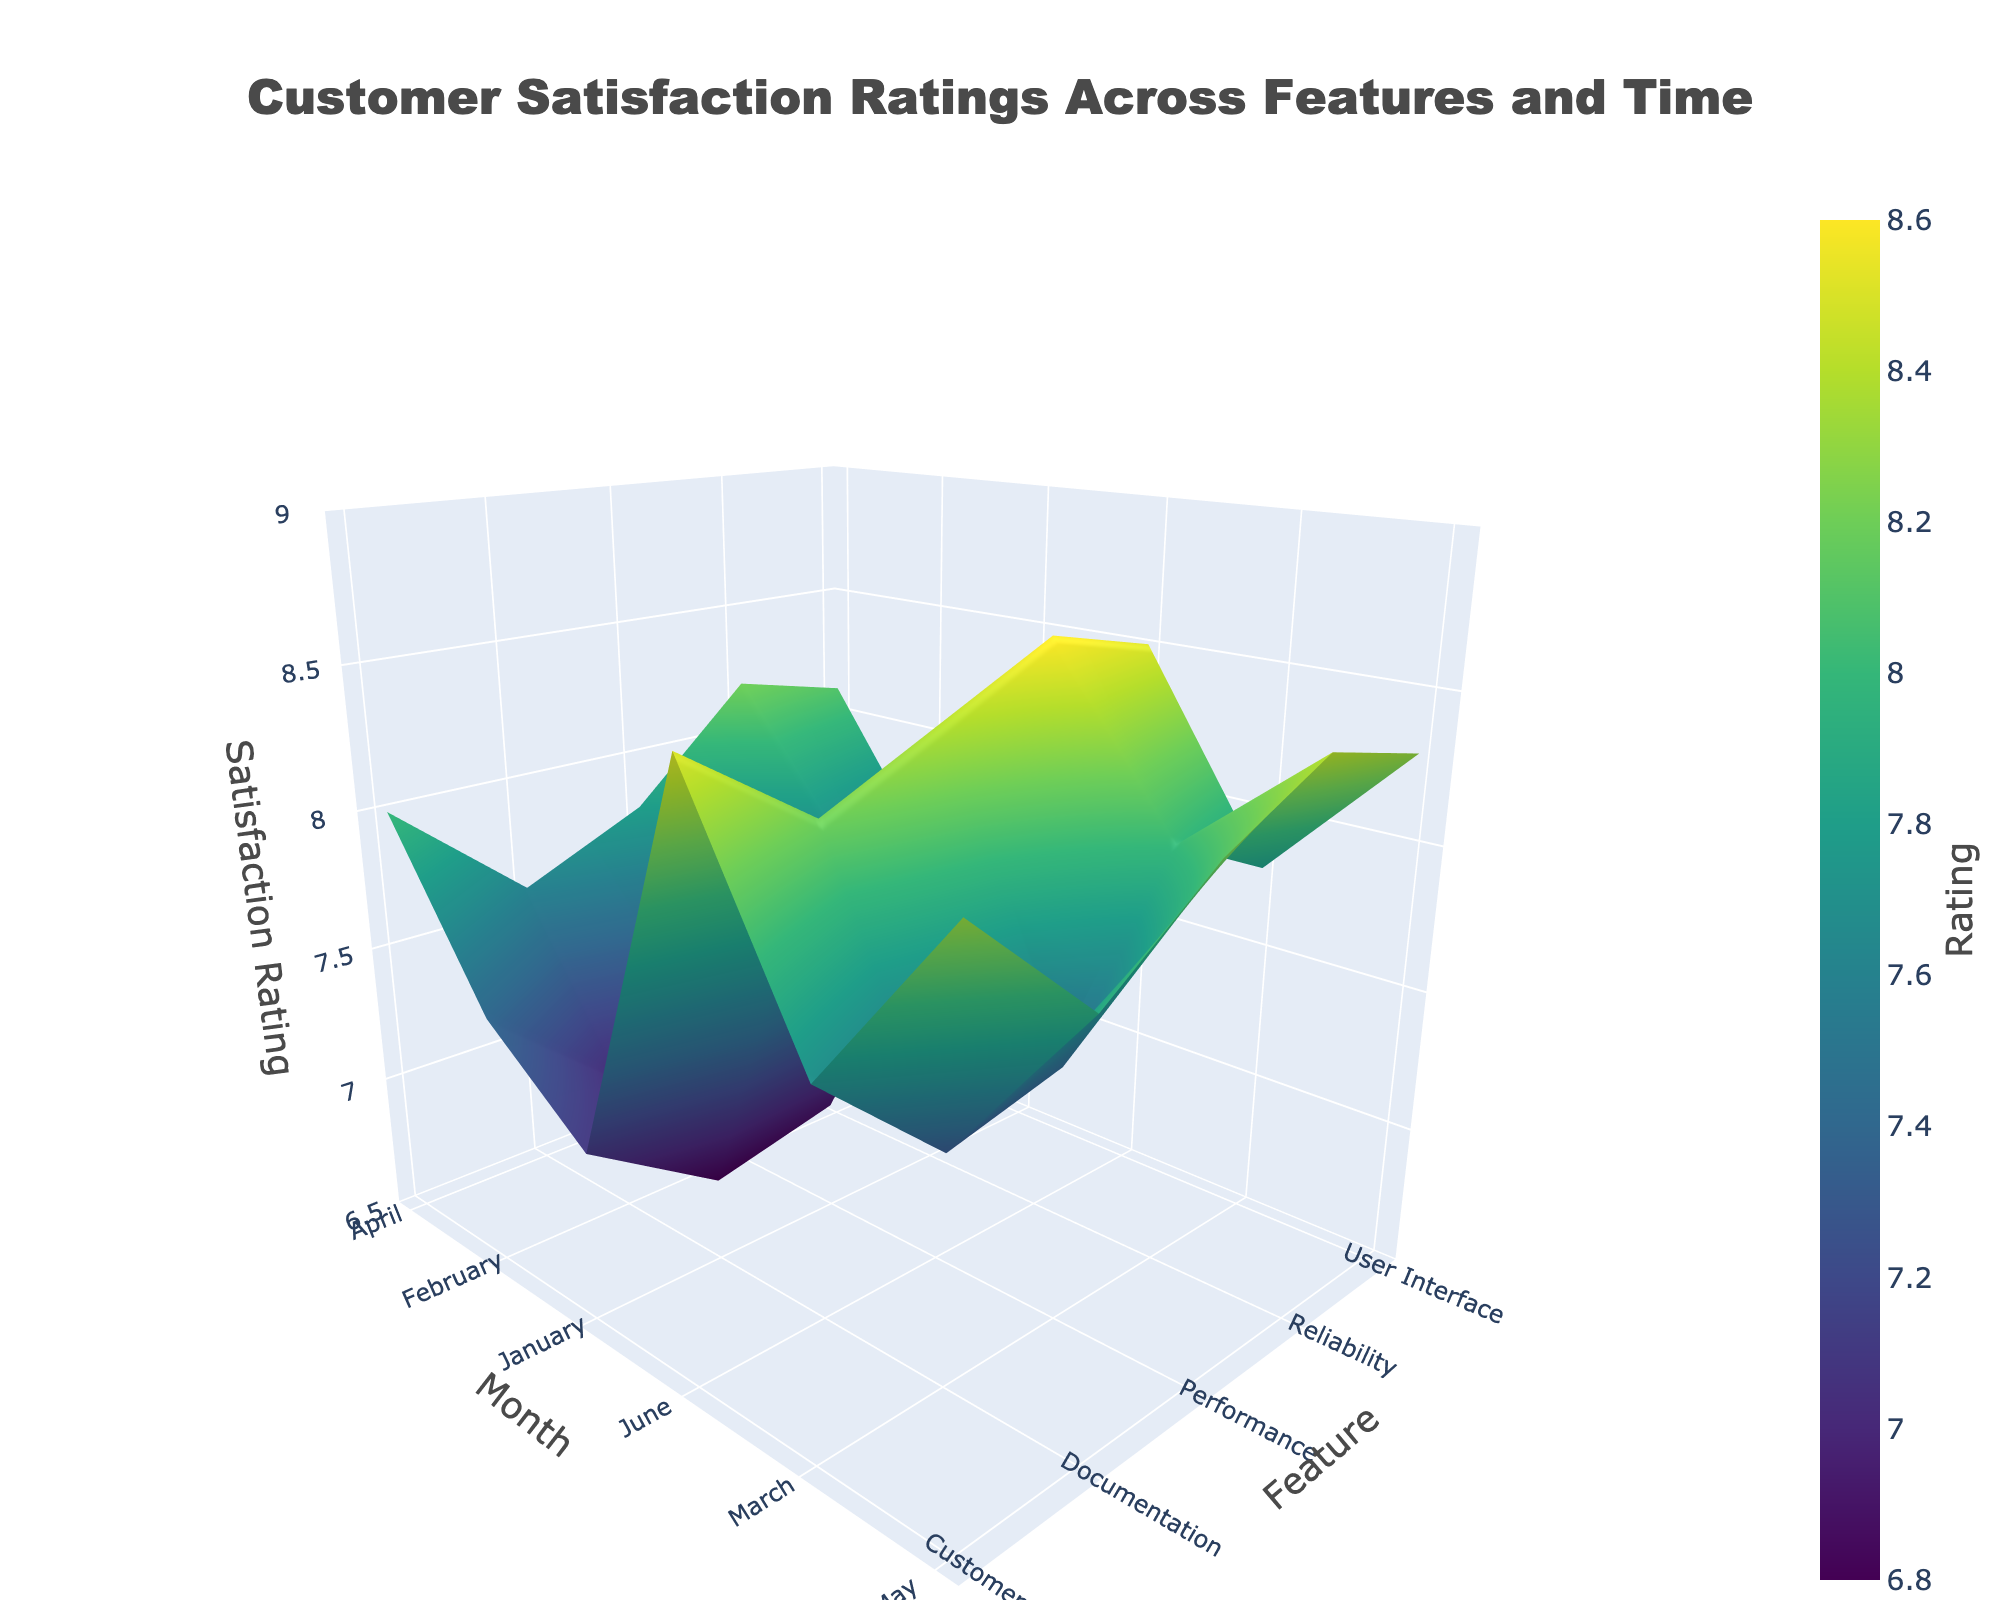What is the title of the plot? The title is usually positioned at the top of the plot in a larger font size and states the main topic of the visualization.
Answer: "Customer Satisfaction Ratings Across Features and Time" Which feature has the highest satisfaction rating in June? To find this, locate the column for June on the x-axis and look for the peak value within that month.
Answer: "Reliability" Which month shows the lowest satisfaction rating for Documentation? Locate the Documentation row on the y-axis and identify the lowest value within that row.
Answer: "January" What is the difference in satisfaction rating for the User Interface between January and June? Find the satisfaction ratings for the User Interface in January and June and then subtract the January value from the June value.
Answer: 1.3 Which feature shows the most improvement in satisfaction rating from January to June? Calculate the difference in satisfaction ratings for each feature between January and June, and identify the feature with the largest positive difference.
Answer: "Customer Support" How do satisfaction ratings for Performance compare between February and April? Find the satisfaction ratings for Performance in February and April and compare the two values.
Answer: "April is higher by 0.7" What is the average satisfaction rating for Customer Support across all months? Add the satisfaction ratings for Customer Support for each month and divide by the number of months (6).
Answer: 7.833 Which month shows the greatest variation in satisfaction ratings across all features? Find the range (difference between maximum and minimum values) of satisfaction ratings for each month and identify the month with the highest range.
Answer: "January" Does any feature have a consistent satisfaction rating increase from January to June? Track the satisfaction ratings for each feature month by month to see if they consistently increase every month.
Answer: "Yes, all features" What is the median satisfaction rating for Reliability from January to June? List the satisfaction ratings for Reliability from January to June in numerical order and find the middle value.
Answer: 8.1 